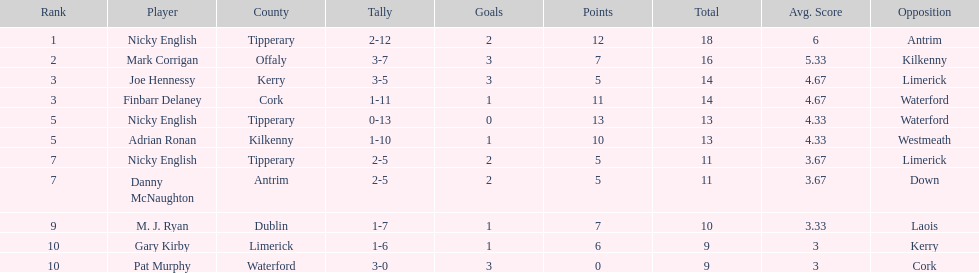What player got 10 total points in their game? M. J. Ryan. 